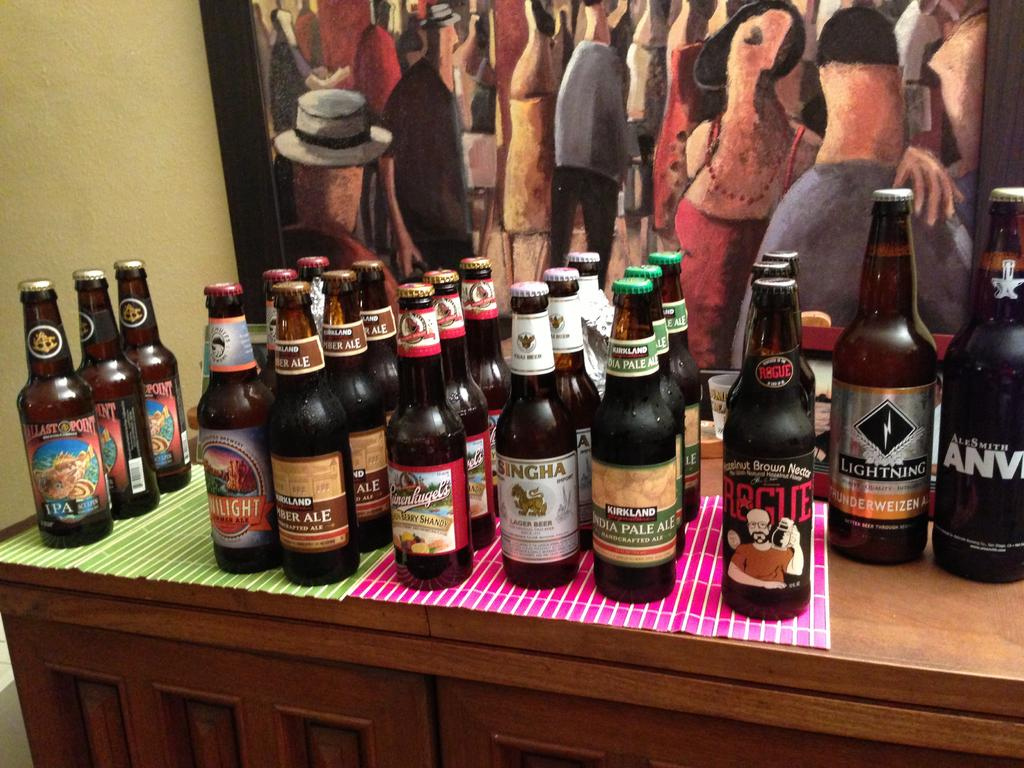<image>
Create a compact narrative representing the image presented. A variety of beer bottles including one from the Kirkland brand. 